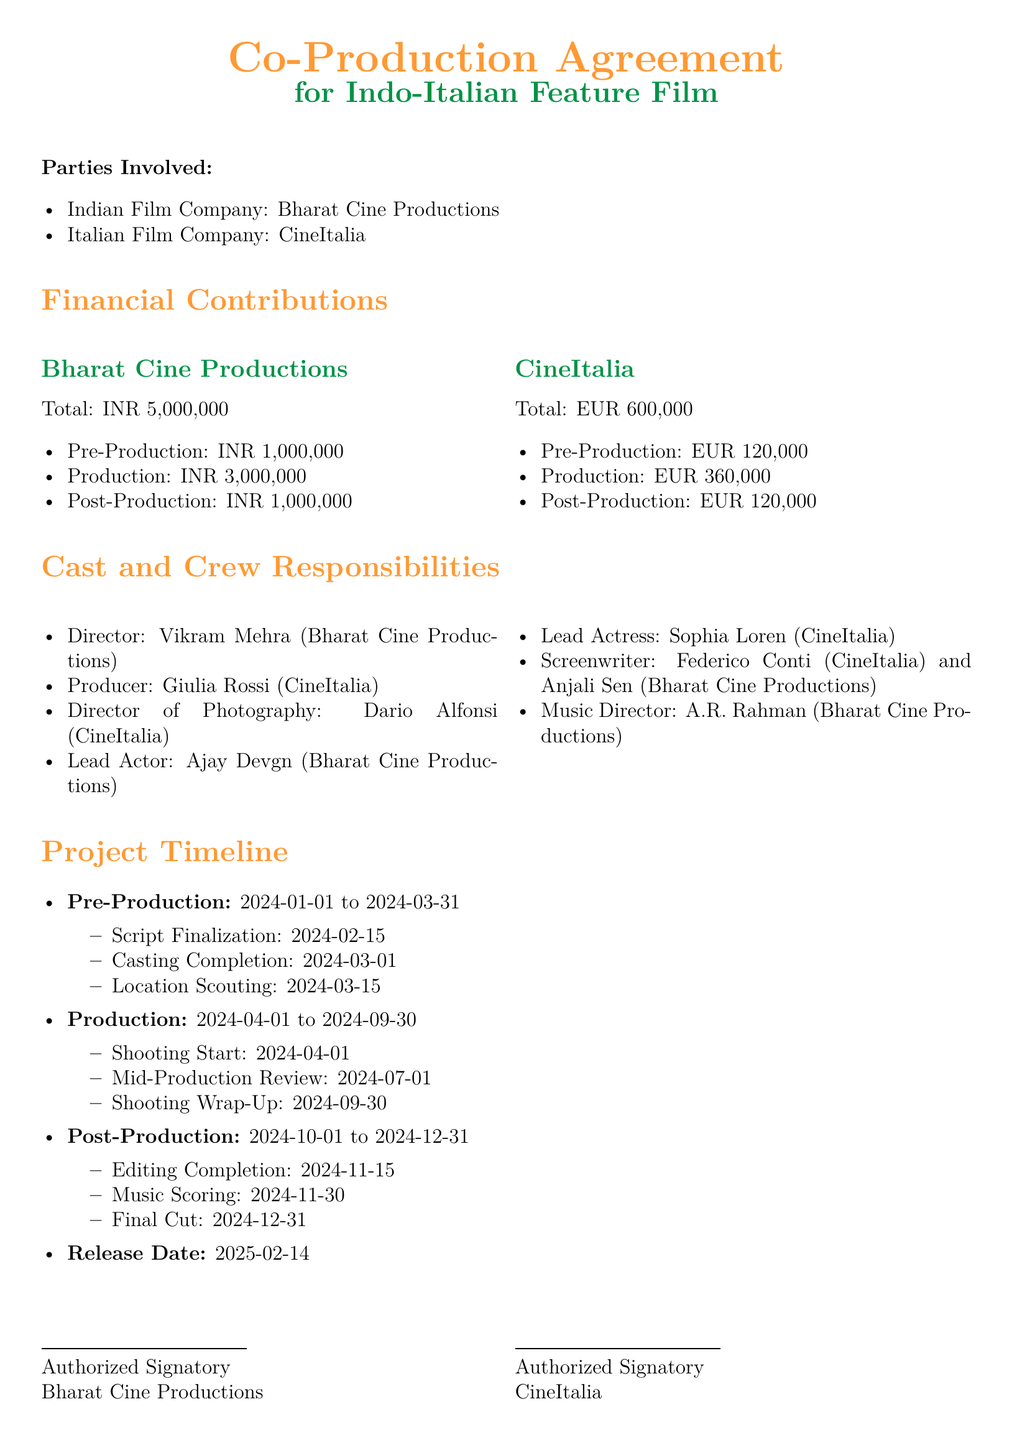What is the total financial contribution of Bharat Cine Productions? The total financial contribution is specified in the document under Bharat Cine Productions, which is INR 5,000,000.
Answer: INR 5,000,000 What is the production budget contribution from CineItalia? The production budget contribution from CineItalia is detailed in the financial contributions section, which is EUR 360,000.
Answer: EUR 360,000 Who is the lead actress in the film? The document lists the lead actress as Sophia Loren under the cast and crew responsibilities section.
Answer: Sophia Loren What is the timeline for script finalization? The document outlines that the script finalization occurs during the pre-production phase, specifically on 2024-02-15.
Answer: 2024-02-15 When does the production phase begin? According to the project timeline, the production phase starts on 2024-04-01.
Answer: 2024-04-01 Who is responsible for music direction? The music director is mentioned in the cast and crew responsibilities section, which is A.R. Rahman.
Answer: A.R. Rahman What is the final cut completion date? The final cut completion date is detailed in the post-production timeline, which is 2024-12-31.
Answer: 2024-12-31 Who are the screenwriters for the film? The document lists Federico Conti and Anjali Sen as the screenwriters in the cast and crew responsibilities section.
Answer: Federico Conti and Anjali Sen What is the release date of the film? The release date is specified at the end of the project timeline as 2025-02-14.
Answer: 2025-02-14 